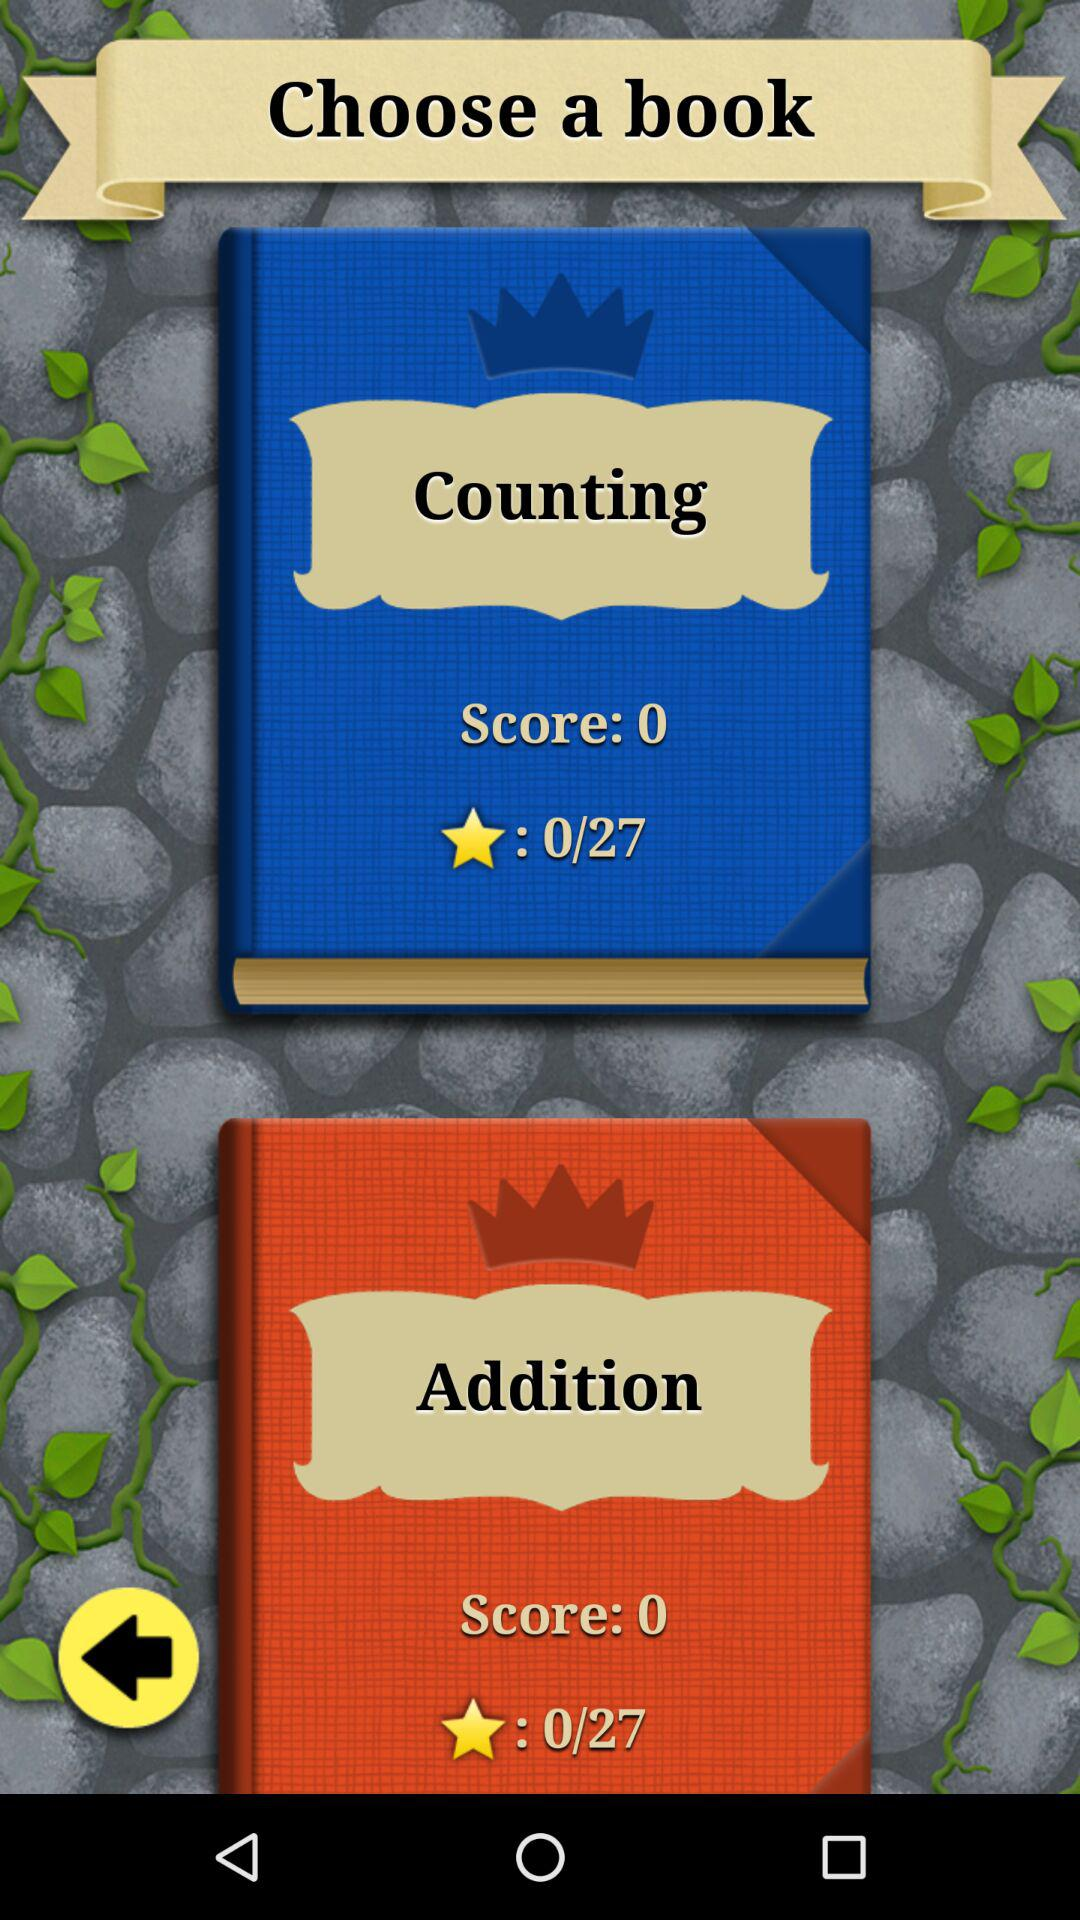What is the duration of the "Counting" book?
When the provided information is insufficient, respond with <no answer>. <no answer> 